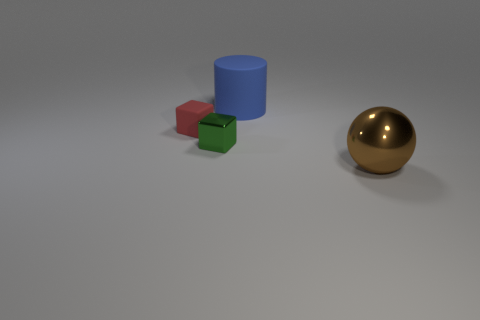What number of other things are there of the same shape as the tiny shiny object?
Your answer should be compact. 1. Is there a tiny gray block that has the same material as the big blue cylinder?
Your answer should be very brief. No. Does the large object that is in front of the large blue cylinder have the same material as the small object to the right of the tiny red rubber cube?
Keep it short and to the point. Yes. How many big yellow rubber cylinders are there?
Keep it short and to the point. 0. The rubber thing to the left of the blue thing has what shape?
Offer a terse response. Cube. What number of other objects are there of the same size as the brown shiny ball?
Your answer should be very brief. 1. Do the large object that is on the left side of the metallic ball and the metallic thing that is left of the matte cylinder have the same shape?
Give a very brief answer. No. How many small green things are in front of the brown metallic object?
Your answer should be very brief. 0. What color is the large thing behind the brown sphere?
Make the answer very short. Blue. The other object that is the same shape as the tiny red rubber thing is what color?
Offer a very short reply. Green. 